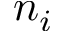Convert formula to latex. <formula><loc_0><loc_0><loc_500><loc_500>n _ { i }</formula> 